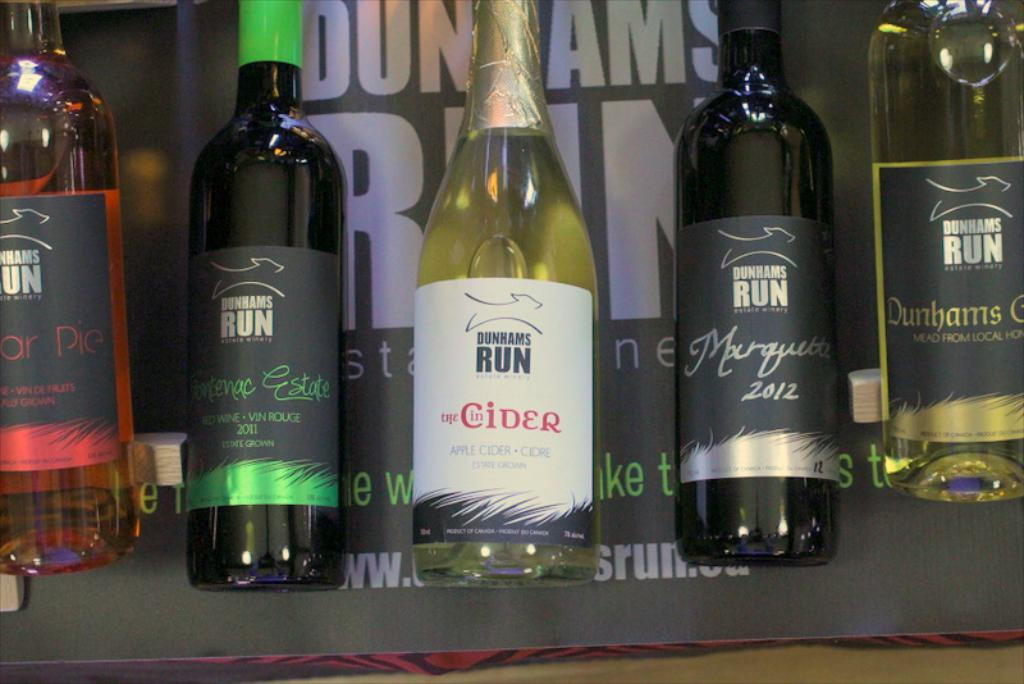What is unique about the apple cider shown in the image? The apple cider, branded as 'Dunhams Run the Cider,' appears to be a sparkling cider, which suggests a refreshing, effervescent quality. Made from local apples, its uniqueness may lie in its sourcing of local produce, potentially offering a crisp and fresh taste that captures the essence of the region's apple orchards. 